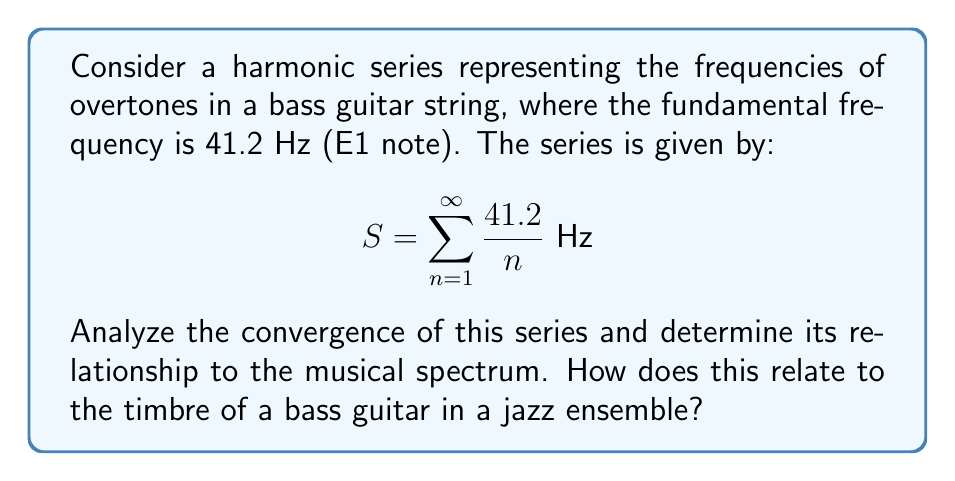Help me with this question. Let's analyze this series step-by-step:

1) First, we need to recognize that this is a scalar multiple of the harmonic series:

   $$S = 41.2 \sum_{n=1}^{\infty} \frac{1}{n}$$

2) The harmonic series $\sum_{n=1}^{\infty} \frac{1}{n}$ is a well-known divergent series. We can prove this using the integral test:

   $$\int_{1}^{\infty} \frac{1}{x} dx = \lim_{b \to \infty} \ln(b) - \ln(1) = \infty$$

3) Since the integral diverges, the series also diverges.

4) Multiplying a divergent series by a non-zero constant (41.2 in this case) doesn't change its divergence. Therefore, $S$ is also divergent.

5) In musical terms, this means that theoretically, a bass guitar string produces an infinite number of overtones, each with a frequency that's an integer multiple of the fundamental frequency.

6) However, in practice, higher overtones become increasingly weak and eventually inaudible. The strength and number of audible overtones contribute to the instrument's timbre.

7) In a jazz ensemble, the rich overtone structure of the bass guitar allows it to provide a full, warm foundation for the band. The lower overtones (first few terms of the series) are particularly important for the characteristic sound of the bass.

8) The divergence of the series mathematically represents the theoretical possibility of infinite overtones, but in reality, physical limitations of the instrument and human hearing create a finite, but rich, spectrum of frequencies.
Answer: The series diverges, representing theoretically infinite overtones that define the bass guitar's rich timbre in jazz. 